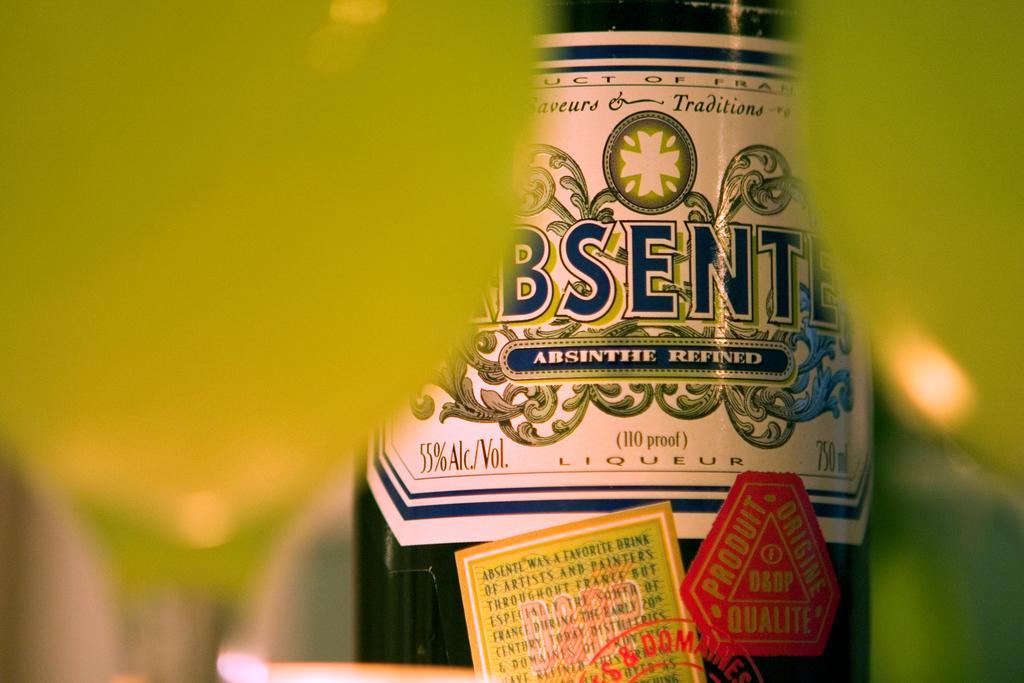<image>
Render a clear and concise summary of the photo. A bottle of Absinthe has 750 milliliters and 55 percent alcohol by volume. 